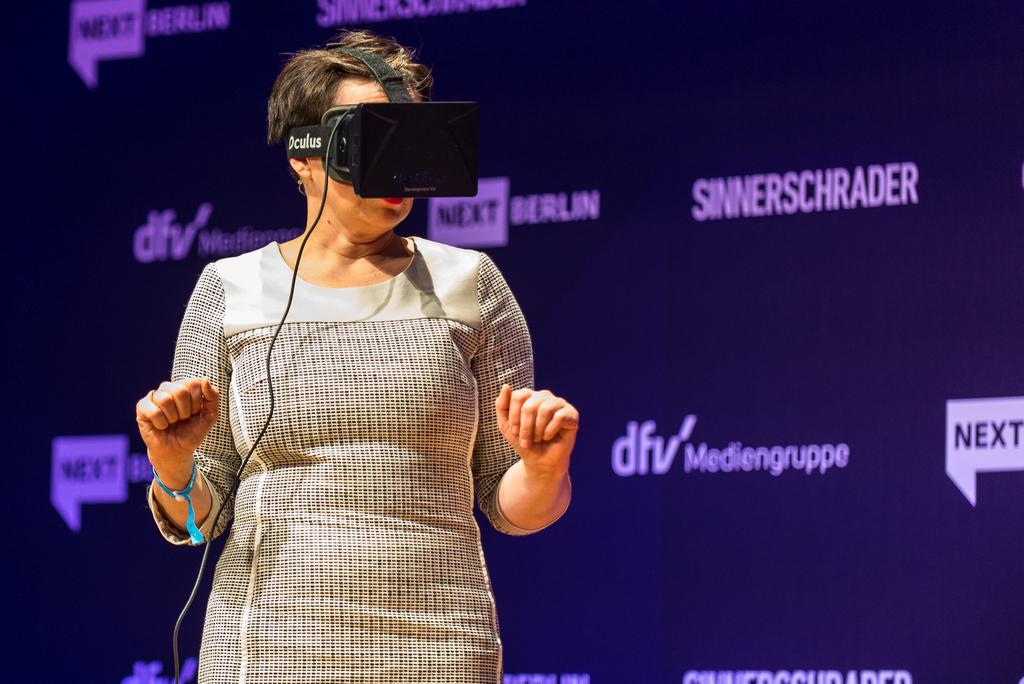Where was the image taken? The image was taken indoors. What can be seen in the background of the image? There is a board with text in the background. Who is the main subject in the image? A woman is standing in the middle of the image. What is the woman wearing in the image? The woman is wearing a virtual 3D device. Can you see the giraffe's grip on the tree branch in the image? There is no giraffe or tree branch present in the image. 